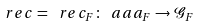Convert formula to latex. <formula><loc_0><loc_0><loc_500><loc_500>\ r e c = \ r e c _ { F } \colon \ a a a _ { F } \to \mathcal { G } _ { F }</formula> 